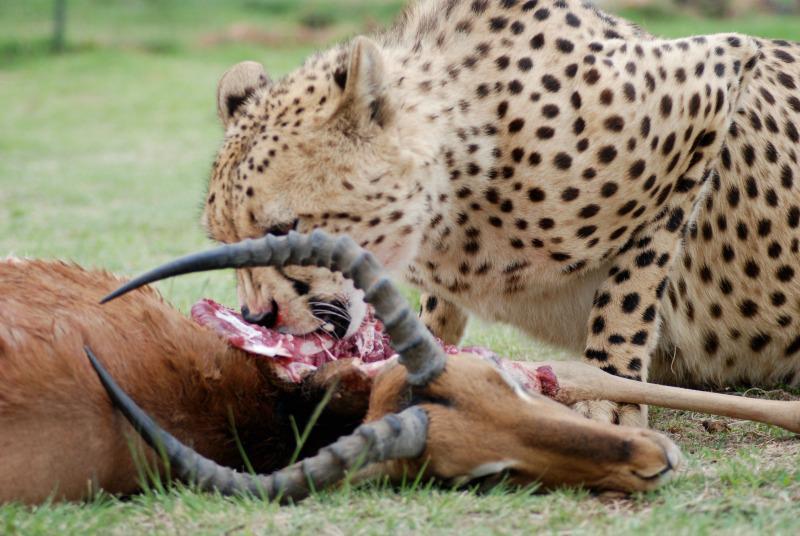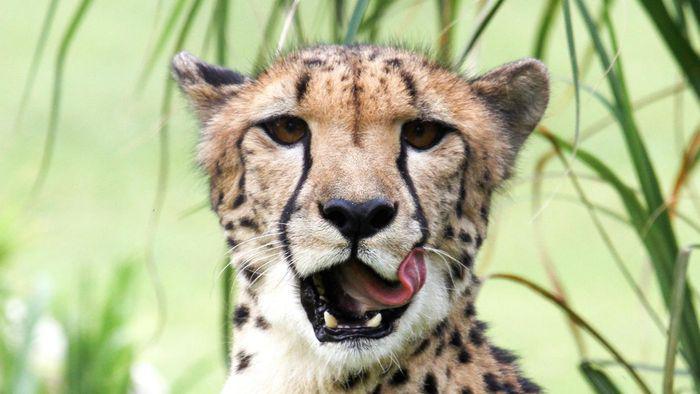The first image is the image on the left, the second image is the image on the right. For the images displayed, is the sentence "One image shows a reclining adult spotted wild cat posed with a cub." factually correct? Answer yes or no. No. The first image is the image on the left, the second image is the image on the right. Assess this claim about the two images: "In one of the images there are two cheetahs laying next to each other.". Correct or not? Answer yes or no. No. 